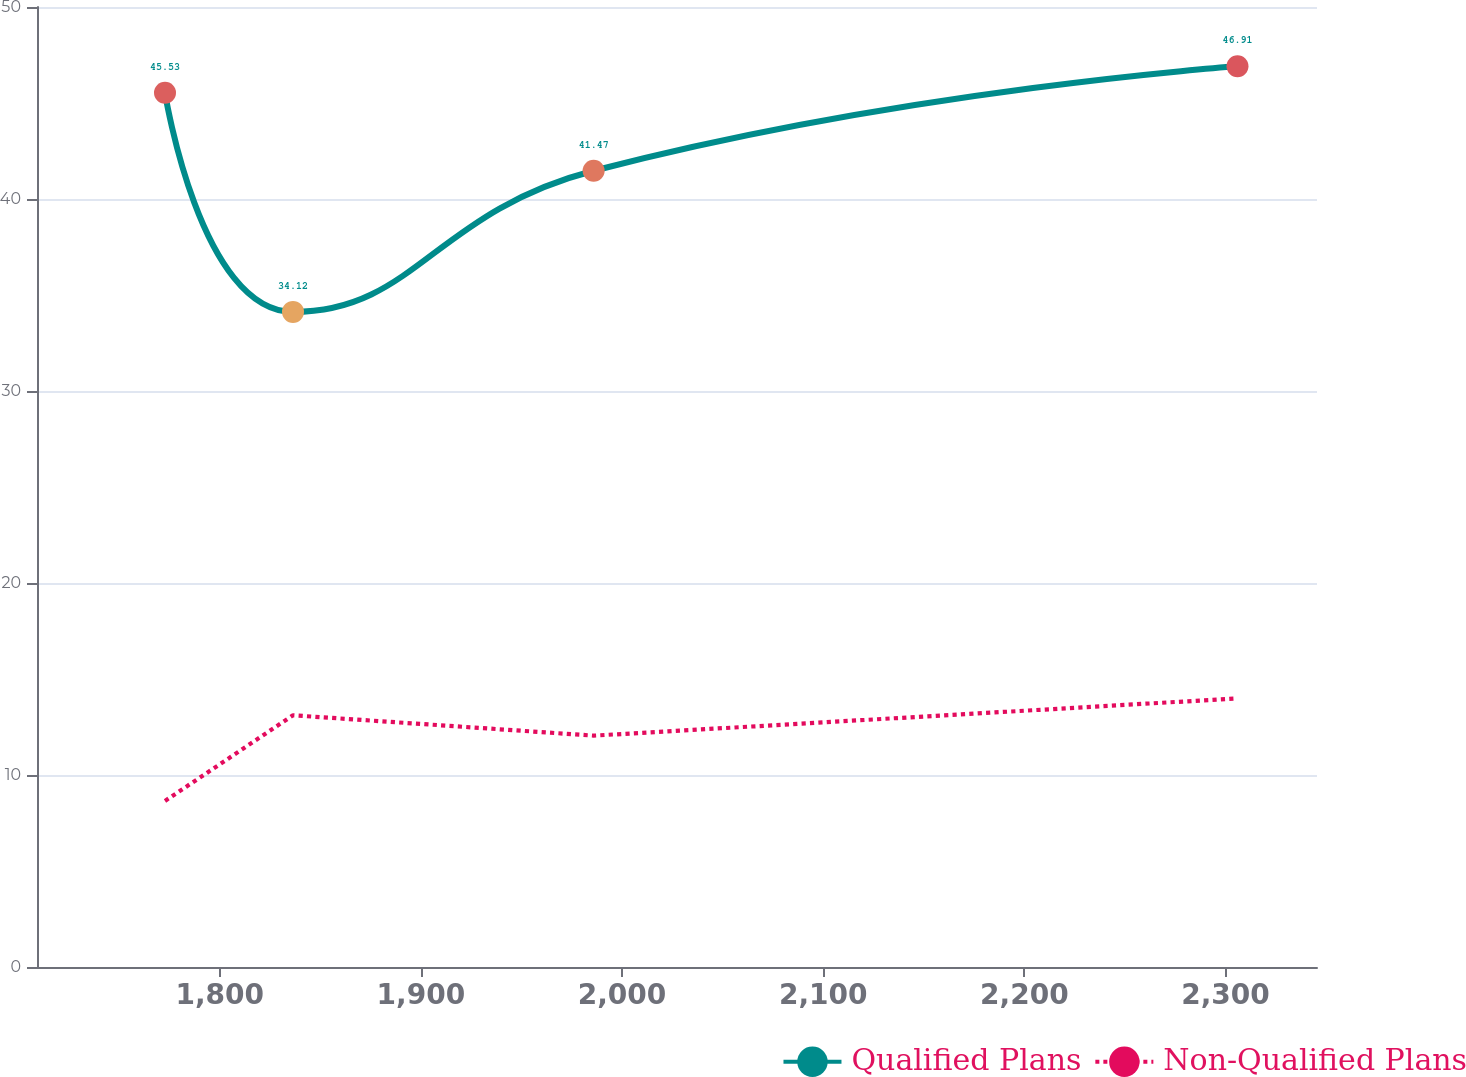Convert chart to OTSL. <chart><loc_0><loc_0><loc_500><loc_500><line_chart><ecel><fcel>Qualified Plans<fcel>Non-Qualified Plans<nl><fcel>1772.8<fcel>45.53<fcel>8.65<nl><fcel>1836.43<fcel>34.12<fcel>13.11<nl><fcel>1985.88<fcel>41.47<fcel>12.05<nl><fcel>2305.95<fcel>46.91<fcel>13.99<nl><fcel>2409.11<fcel>48.29<fcel>11.52<nl></chart> 